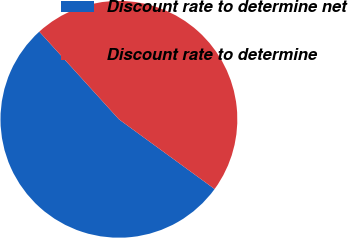Convert chart. <chart><loc_0><loc_0><loc_500><loc_500><pie_chart><fcel>Discount rate to determine net<fcel>Discount rate to determine<nl><fcel>53.24%<fcel>46.76%<nl></chart> 